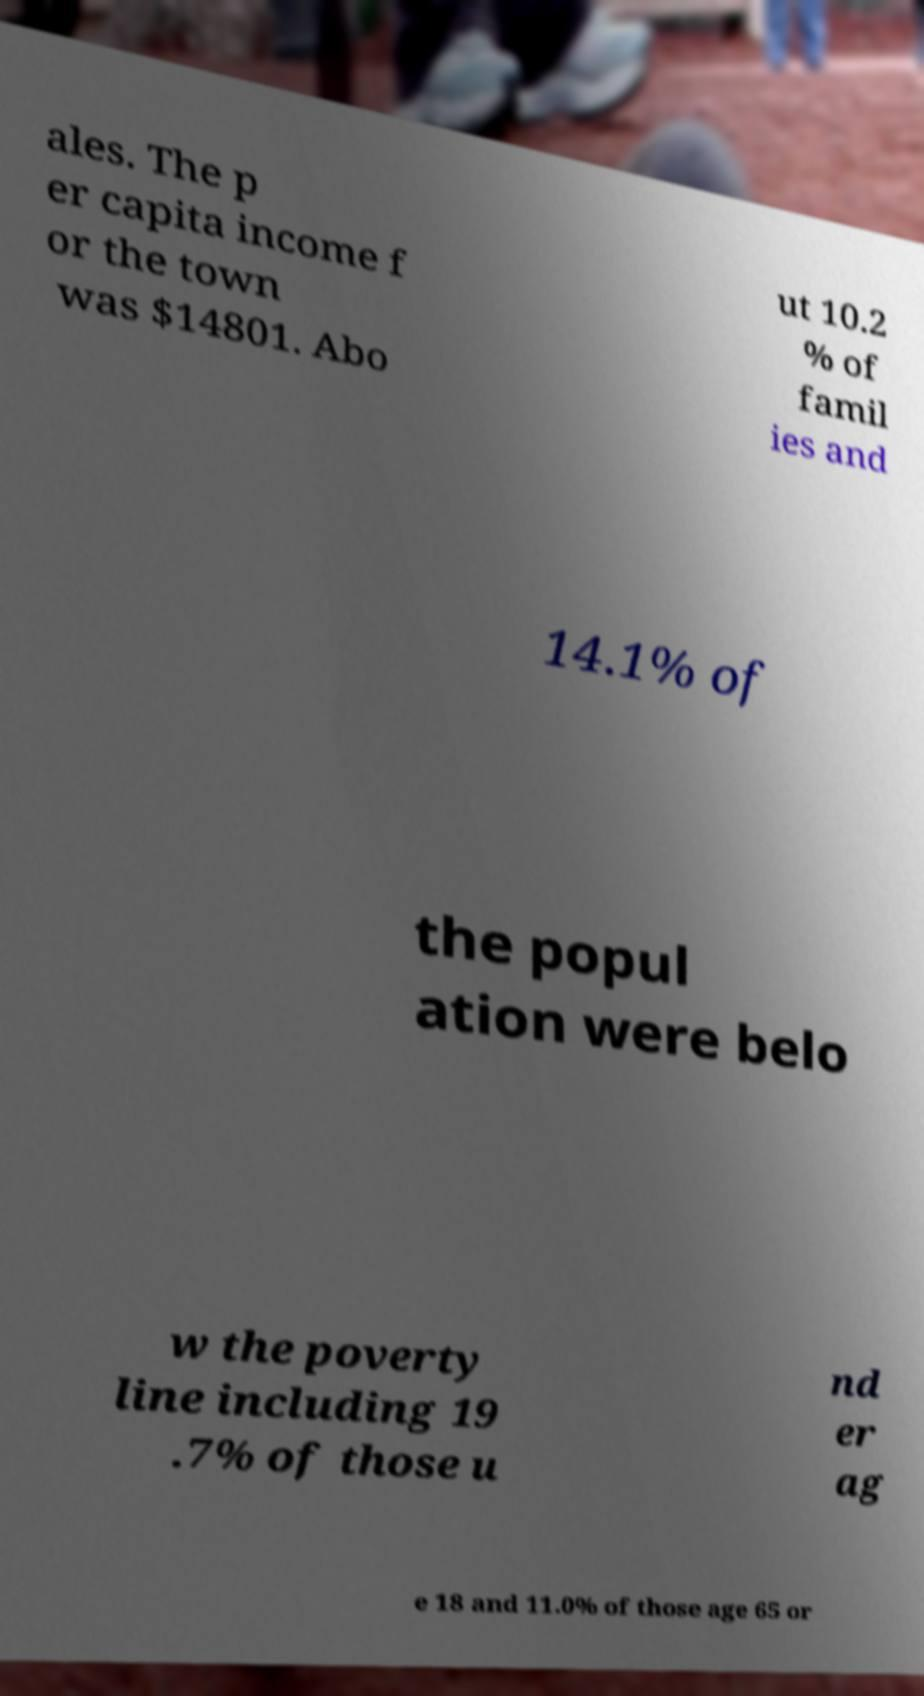For documentation purposes, I need the text within this image transcribed. Could you provide that? ales. The p er capita income f or the town was $14801. Abo ut 10.2 % of famil ies and 14.1% of the popul ation were belo w the poverty line including 19 .7% of those u nd er ag e 18 and 11.0% of those age 65 or 